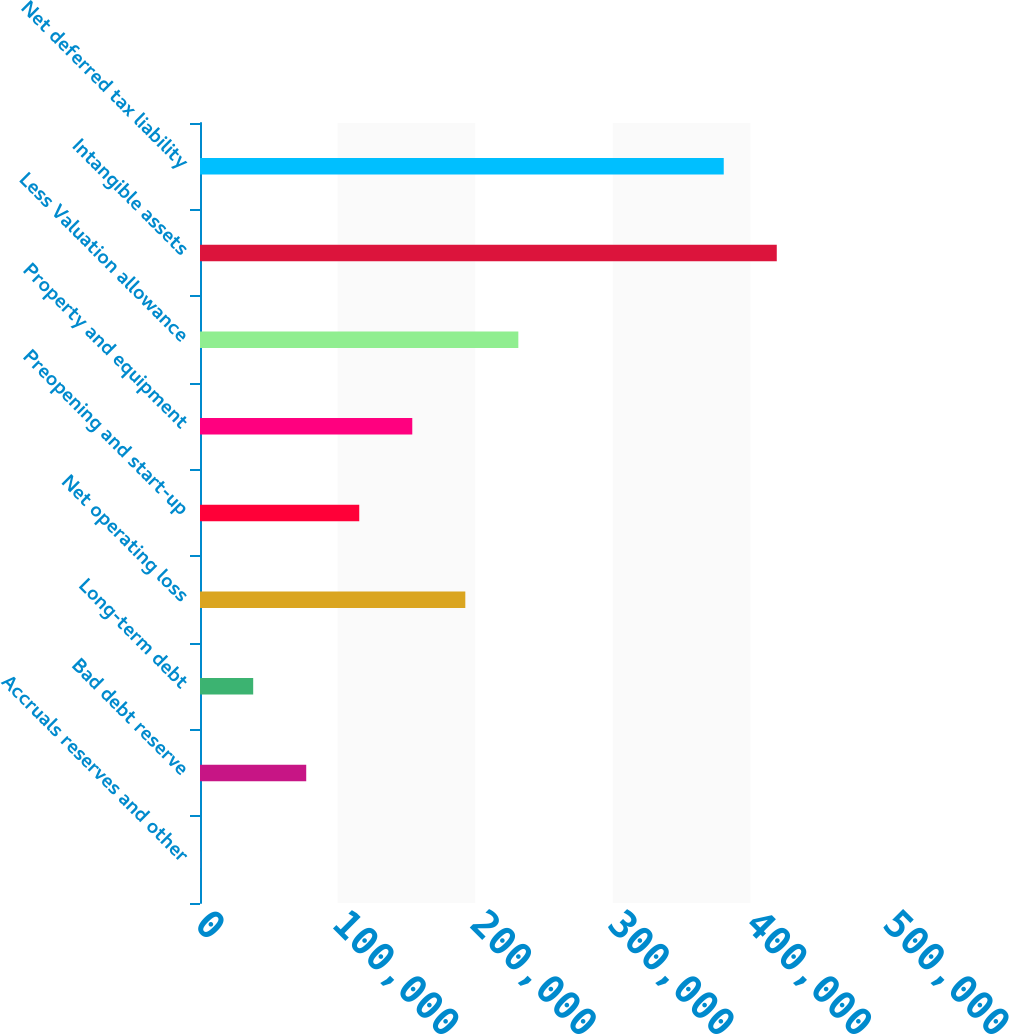Convert chart. <chart><loc_0><loc_0><loc_500><loc_500><bar_chart><fcel>Accruals reserves and other<fcel>Bad debt reserve<fcel>Long-term debt<fcel>Net operating loss<fcel>Preopening and start-up<fcel>Property and equipment<fcel>Less Valuation allowance<fcel>Intangible assets<fcel>Net deferred tax liability<nl><fcel>121<fcel>77196.2<fcel>38658.6<fcel>192809<fcel>115734<fcel>154271<fcel>231347<fcel>419166<fcel>380628<nl></chart> 